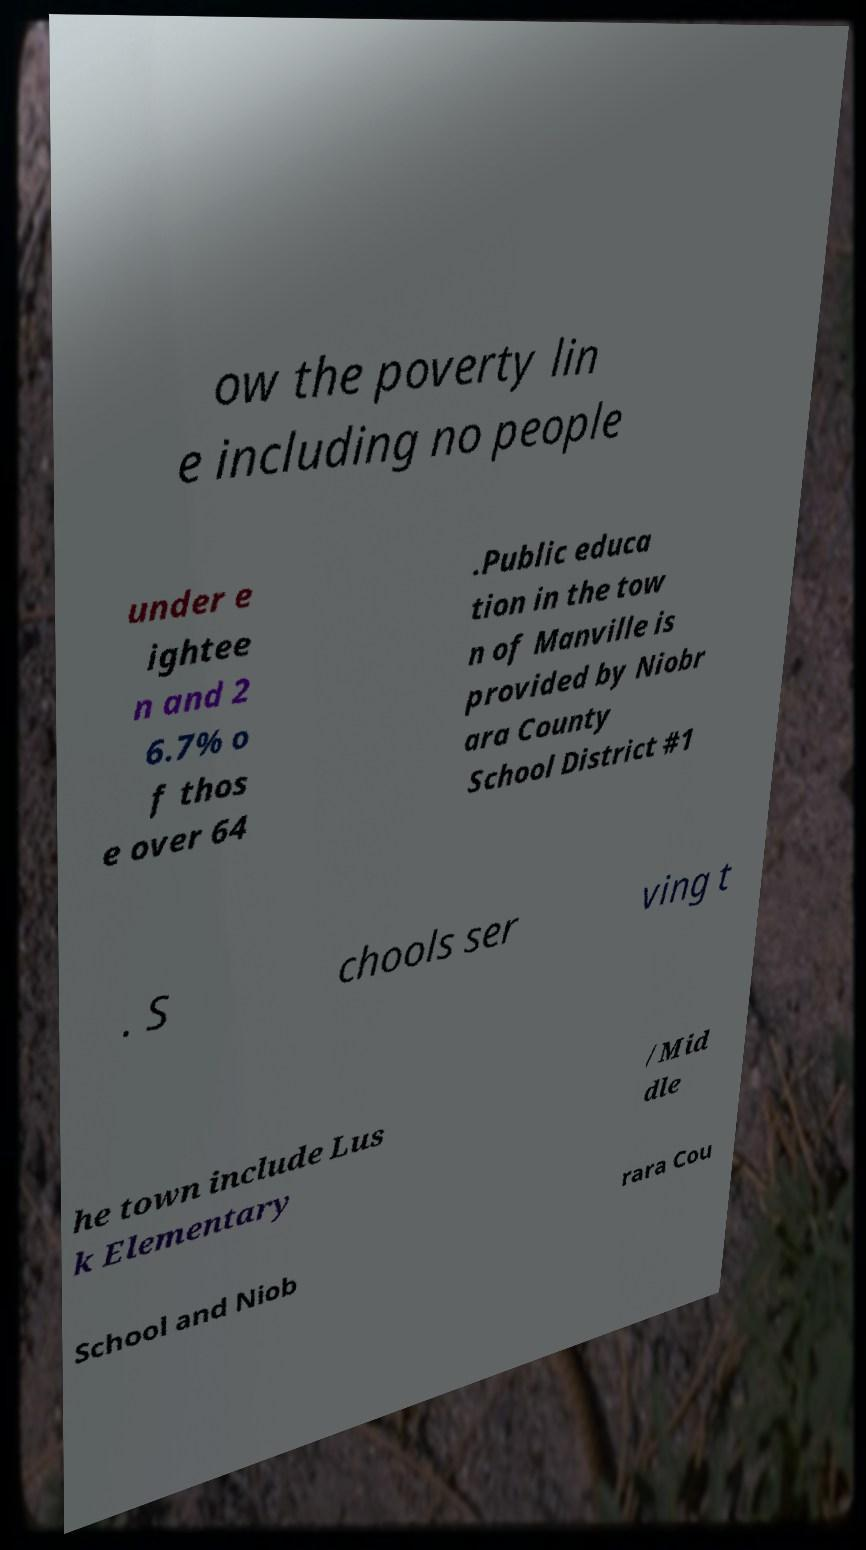There's text embedded in this image that I need extracted. Can you transcribe it verbatim? ow the poverty lin e including no people under e ightee n and 2 6.7% o f thos e over 64 .Public educa tion in the tow n of Manville is provided by Niobr ara County School District #1 . S chools ser ving t he town include Lus k Elementary /Mid dle School and Niob rara Cou 